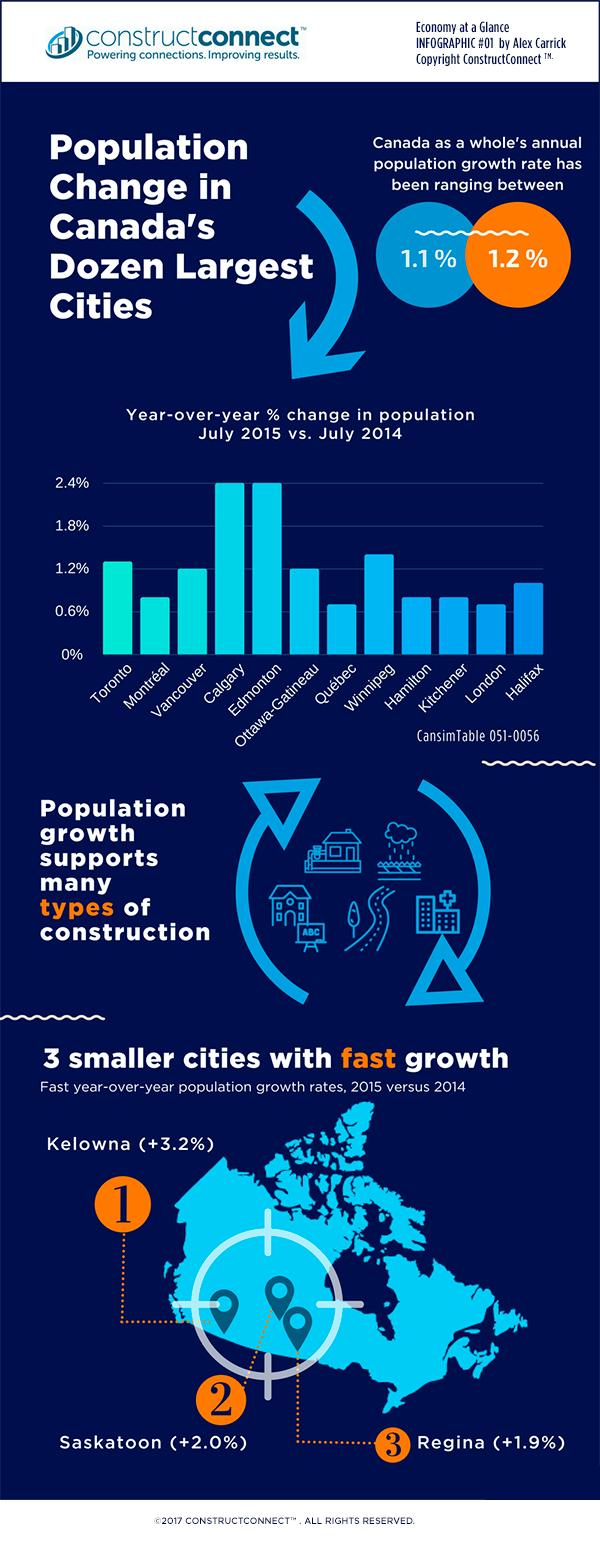Point out several critical features in this image. Quebec and London have experienced the smallest percentage change in population among the cities surveyed. The cities of Calgary and Edmonton have experienced a significant increase in population, with Calgary having the highest percentage change in population among the cities surveyed. According to recent data, the cities of Kelowna, Saskatoon, and Regina in Canada have experienced significant growth in recent years. 